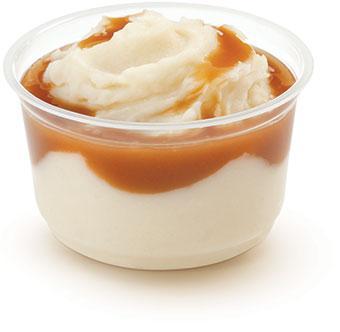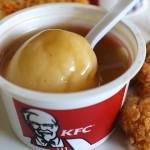The first image is the image on the left, the second image is the image on the right. Analyze the images presented: Is the assertion "There is a utensil in the right hand image." valid? Answer yes or no. Yes. The first image is the image on the left, the second image is the image on the right. Considering the images on both sides, is "The mashed potatoes on the right picture has a spoon in its container." valid? Answer yes or no. Yes. 